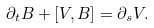Convert formula to latex. <formula><loc_0><loc_0><loc_500><loc_500>\partial _ { t } B + [ V , B ] = \partial _ { s } V .</formula> 